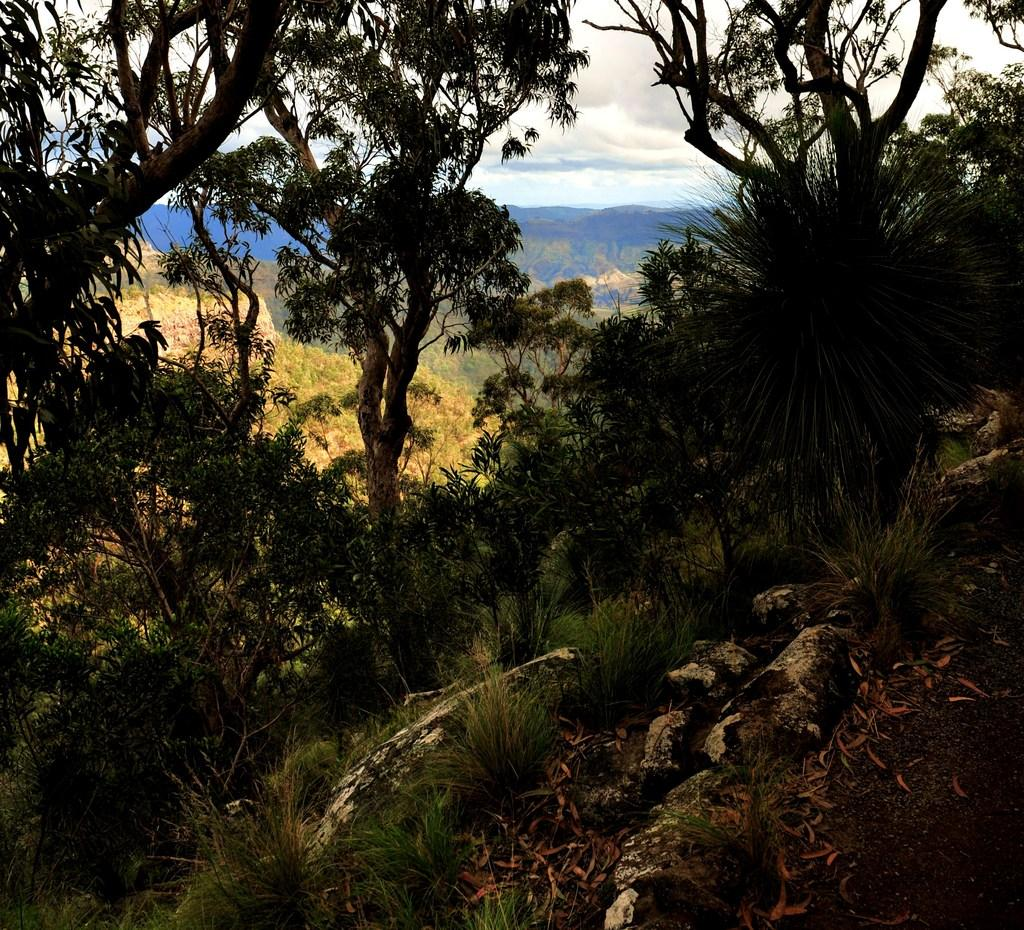What type of vegetation can be seen in the image? There is grass in the image. What can be seen on the ground in the image? There are leaves on a path in the image. What is visible in the distance in the image? There are trees and mountains in the background of the image. What is the condition of the sky in the image? The sky is cloudy in the image. How many minutes does it take to control the holiday in the image? There is no mention of a holiday or control in the image; it features grass, leaves on a path, trees, mountains, and a cloudy sky. 